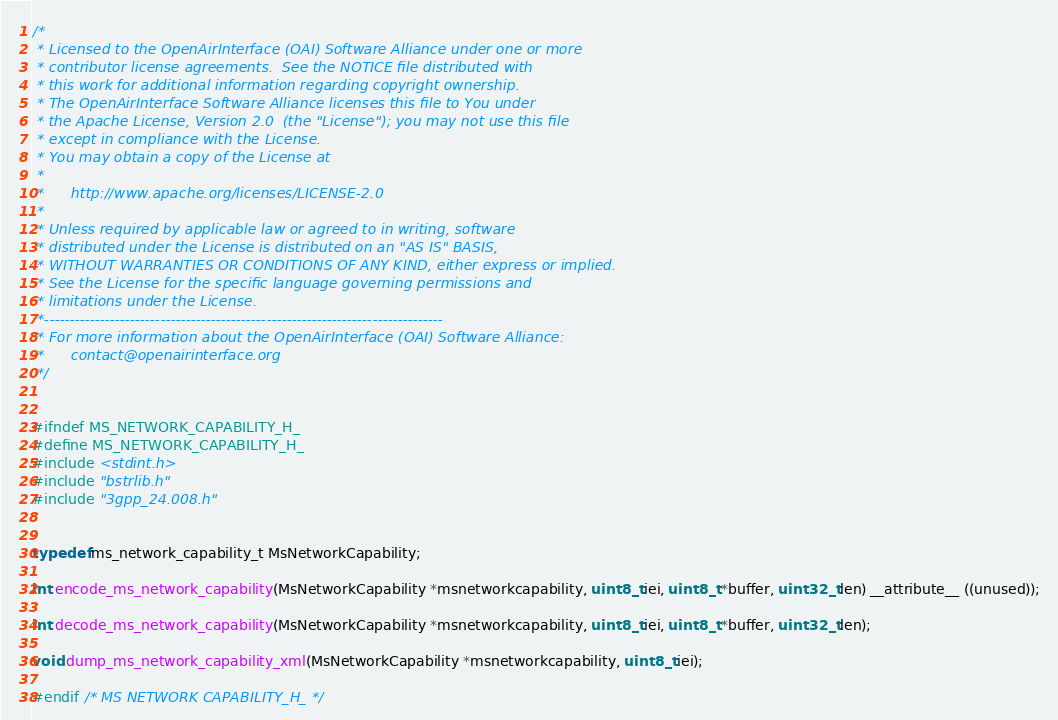<code> <loc_0><loc_0><loc_500><loc_500><_C_>/*
 * Licensed to the OpenAirInterface (OAI) Software Alliance under one or more
 * contributor license agreements.  See the NOTICE file distributed with
 * this work for additional information regarding copyright ownership.
 * The OpenAirInterface Software Alliance licenses this file to You under 
 * the Apache License, Version 2.0  (the "License"); you may not use this file
 * except in compliance with the License.  
 * You may obtain a copy of the License at
 *
 *      http://www.apache.org/licenses/LICENSE-2.0
 *
 * Unless required by applicable law or agreed to in writing, software
 * distributed under the License is distributed on an "AS IS" BASIS,
 * WITHOUT WARRANTIES OR CONDITIONS OF ANY KIND, either express or implied.
 * See the License for the specific language governing permissions and
 * limitations under the License.
 *-------------------------------------------------------------------------------
 * For more information about the OpenAirInterface (OAI) Software Alliance:
 *      contact@openairinterface.org
 */


#ifndef MS_NETWORK_CAPABILITY_H_
#define MS_NETWORK_CAPABILITY_H_
#include <stdint.h>
#include "bstrlib.h"
#include "3gpp_24.008.h"


typedef ms_network_capability_t MsNetworkCapability;

int encode_ms_network_capability(MsNetworkCapability *msnetworkcapability, uint8_t iei, uint8_t *buffer, uint32_t len) __attribute__ ((unused));

int decode_ms_network_capability(MsNetworkCapability *msnetworkcapability, uint8_t iei, uint8_t *buffer, uint32_t len);

void dump_ms_network_capability_xml(MsNetworkCapability *msnetworkcapability, uint8_t iei);

#endif /* MS NETWORK CAPABILITY_H_ */

</code> 